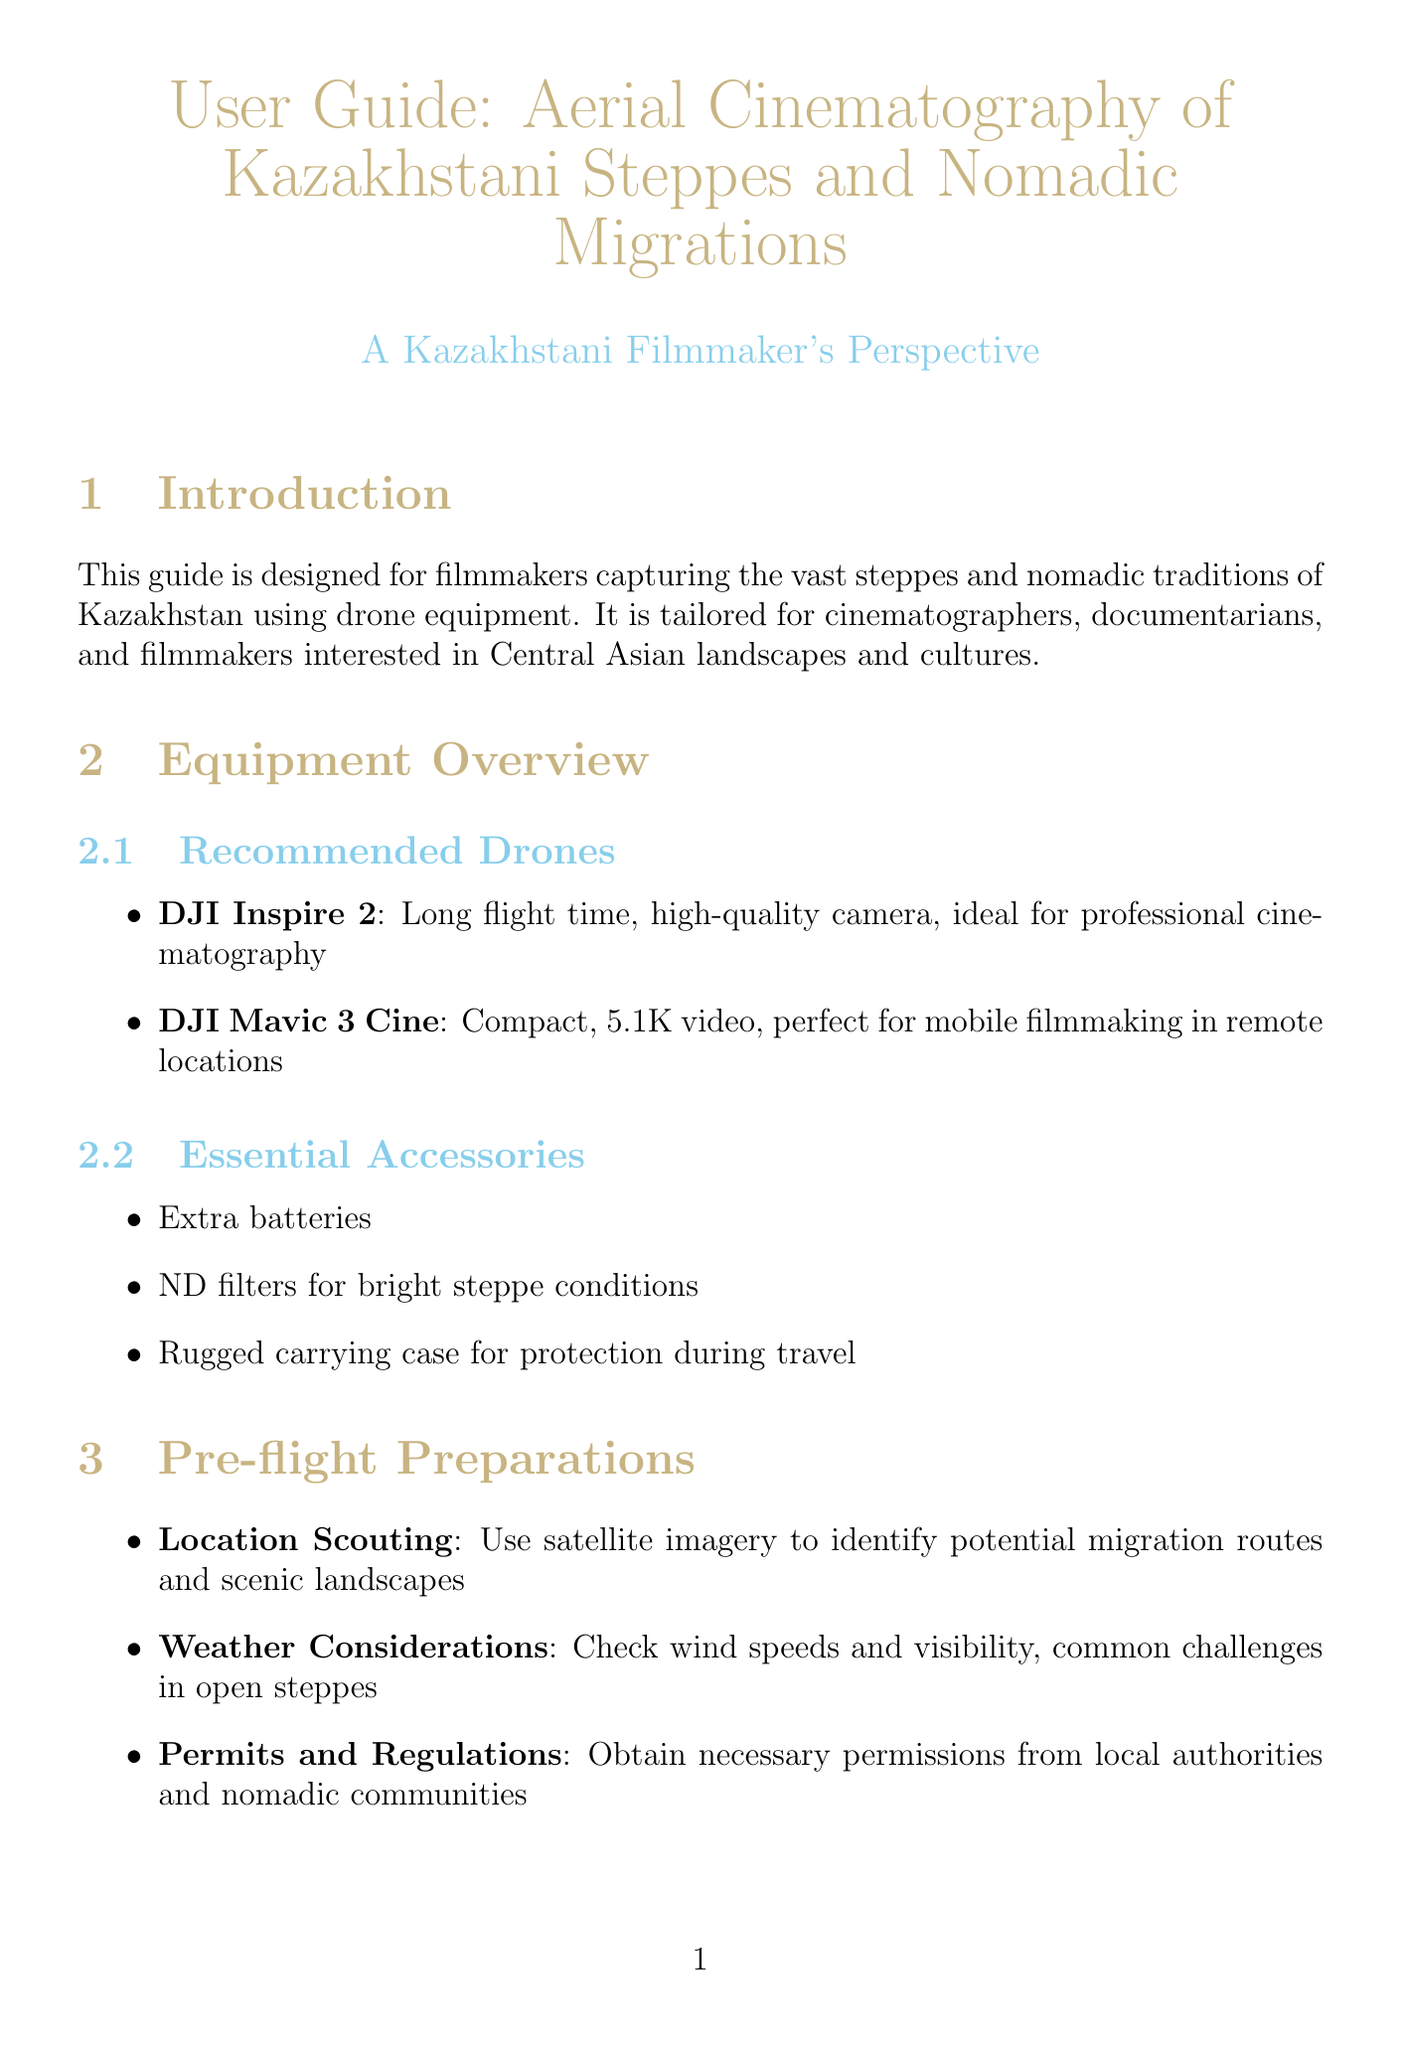What is the purpose of this guide? The guide is designed for filmmakers capturing the vast steppes and nomadic traditions of Kazakhstan using drone equipment.
Answer: Capturing vast steppes and nomadic traditions What are the recommended drones mentioned? The document lists two drones for aerial cinematography.
Answer: DJI Inspire 2, DJI Mavic 3 Cine What should filmmakers check regarding weather? The document emphasizes checking a specific weather factor that affects filming.
Answer: Wind speeds and visibility What is one cultural sensitivity point to consider while filming? The guide advises avoiding certain disturbances when documenting nomadic migrations.
Answer: Disturbing religious or cultural ceremonies Which location was highlighted in a case study about eagle hunters? A case study is provided, indicating a specific region for filming eagle hunters.
Answer: East Kazakhstan Region What is an essential accessory for drone filming in bright steppe conditions? The guide specifies an accessory that helps with filming in bright conditions.
Answer: ND filters What time of day is recommended for capturing landscapes? The document suggests capturing landscapes during a specific time for better visuals.
Answer: Golden hour What should be used to avoid GPS inaccuracies? The manual provides a solution for a common issue related to GPS.
Answer: Manual calibration techniques 